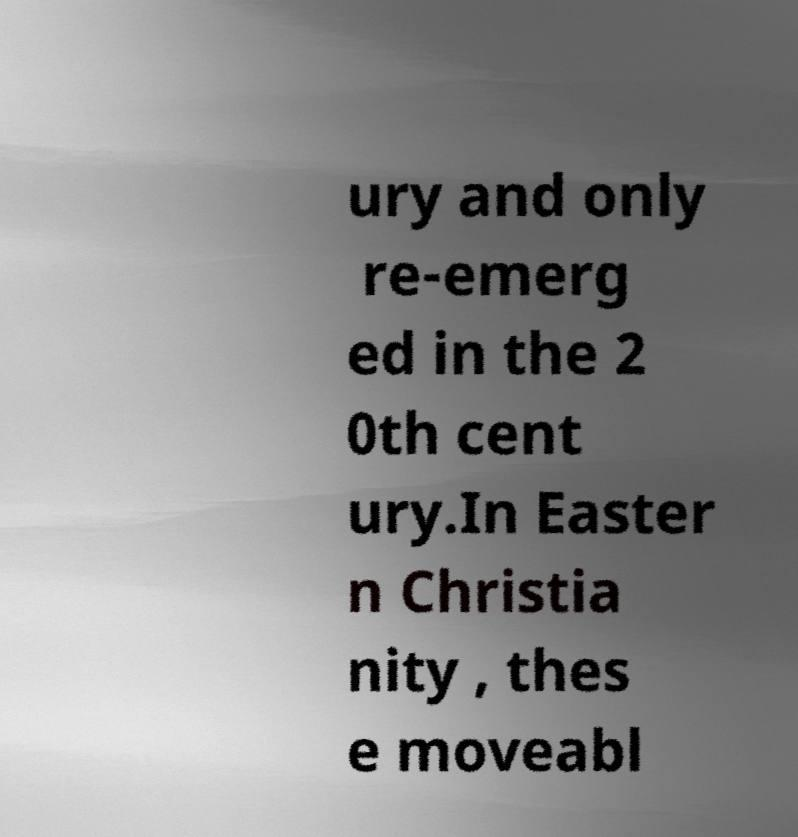Could you assist in decoding the text presented in this image and type it out clearly? ury and only re-emerg ed in the 2 0th cent ury.In Easter n Christia nity , thes e moveabl 